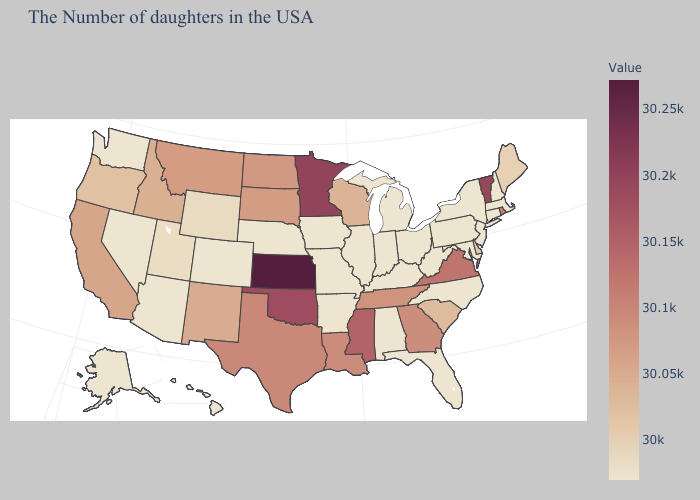Which states have the highest value in the USA?
Be succinct. Kansas. Among the states that border Ohio , which have the lowest value?
Quick response, please. West Virginia, Michigan, Kentucky, Indiana. Which states have the lowest value in the West?
Keep it brief. Colorado, Arizona, Nevada, Washington, Alaska, Hawaii. Which states have the lowest value in the USA?
Concise answer only. Massachusetts, New Hampshire, Connecticut, New York, New Jersey, Maryland, North Carolina, West Virginia, Ohio, Florida, Michigan, Kentucky, Indiana, Alabama, Illinois, Missouri, Arkansas, Iowa, Nebraska, Colorado, Arizona, Nevada, Washington, Alaska, Hawaii. Does the map have missing data?
Short answer required. No. Is the legend a continuous bar?
Keep it brief. Yes. Among the states that border Delaware , does Pennsylvania have the highest value?
Be succinct. Yes. 